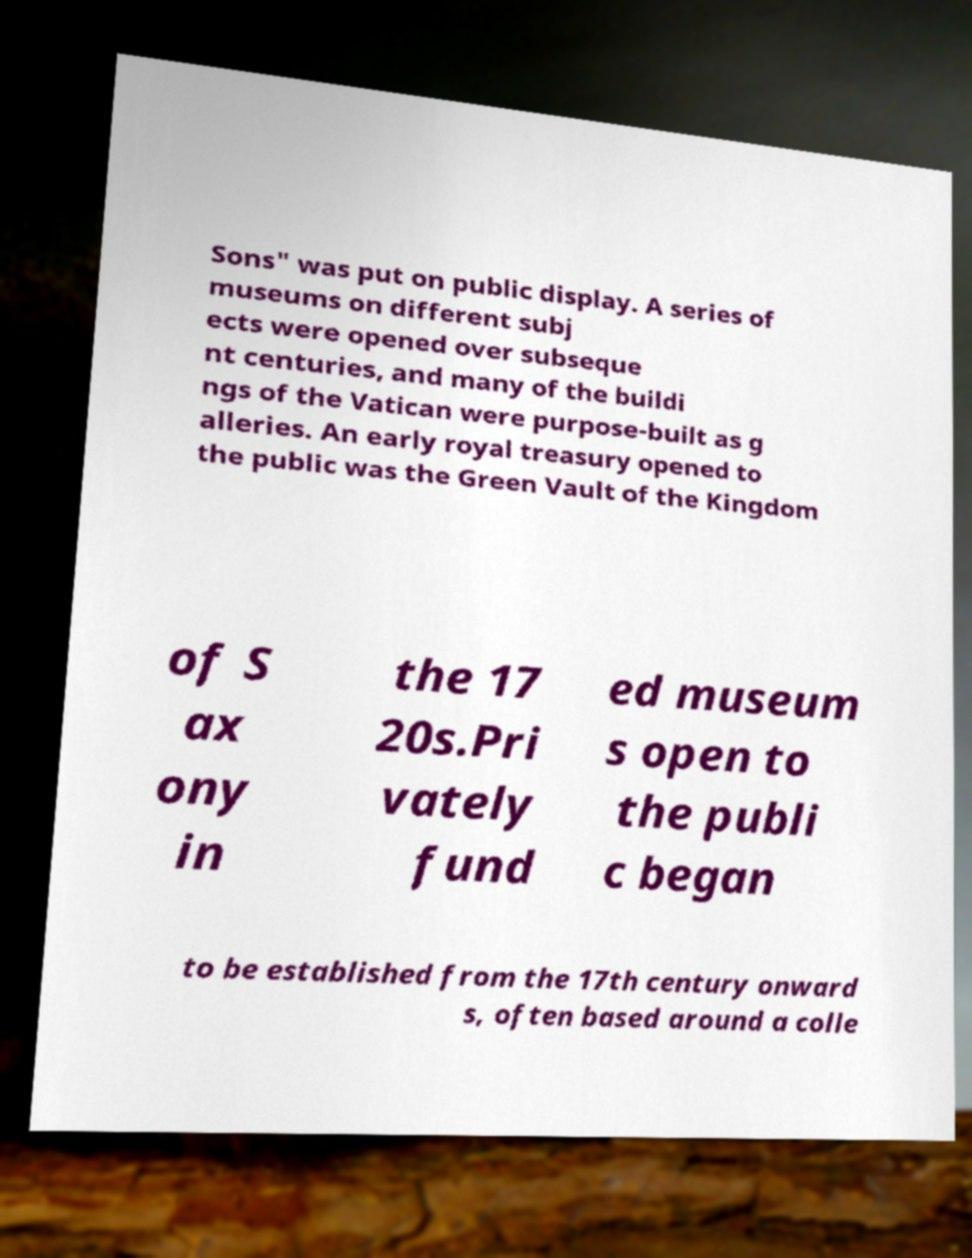Could you assist in decoding the text presented in this image and type it out clearly? Sons" was put on public display. A series of museums on different subj ects were opened over subseque nt centuries, and many of the buildi ngs of the Vatican were purpose-built as g alleries. An early royal treasury opened to the public was the Green Vault of the Kingdom of S ax ony in the 17 20s.Pri vately fund ed museum s open to the publi c began to be established from the 17th century onward s, often based around a colle 